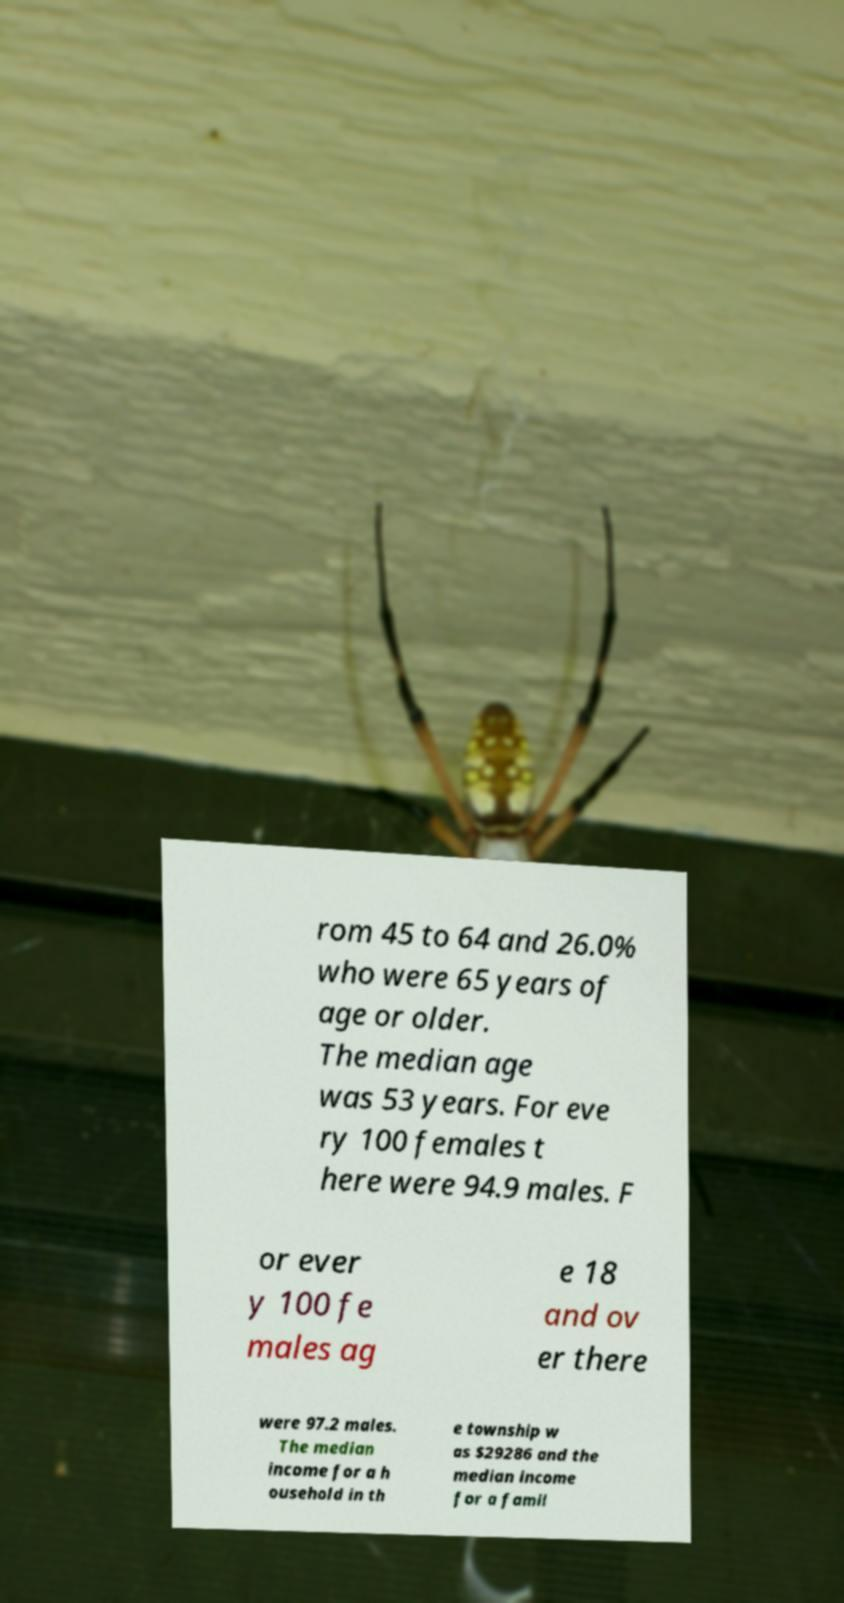I need the written content from this picture converted into text. Can you do that? rom 45 to 64 and 26.0% who were 65 years of age or older. The median age was 53 years. For eve ry 100 females t here were 94.9 males. F or ever y 100 fe males ag e 18 and ov er there were 97.2 males. The median income for a h ousehold in th e township w as $29286 and the median income for a famil 